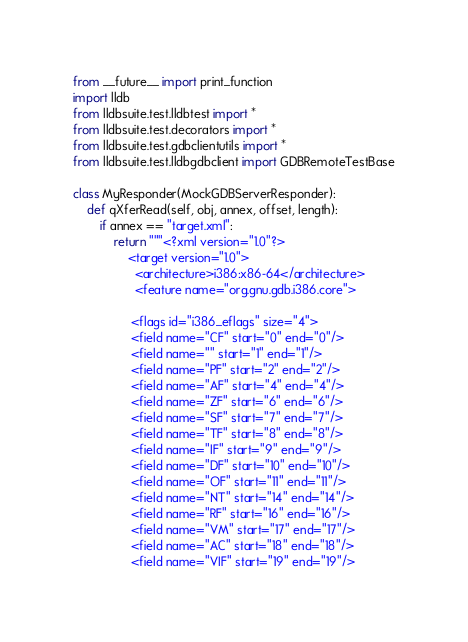Convert code to text. <code><loc_0><loc_0><loc_500><loc_500><_Python_>from __future__ import print_function
import lldb
from lldbsuite.test.lldbtest import *
from lldbsuite.test.decorators import *
from lldbsuite.test.gdbclientutils import *
from lldbsuite.test.lldbgdbclient import GDBRemoteTestBase

class MyResponder(MockGDBServerResponder):
    def qXferRead(self, obj, annex, offset, length):
        if annex == "target.xml":
            return """<?xml version="1.0"?>
                <target version="1.0">
                  <architecture>i386:x86-64</architecture>
                  <feature name="org.gnu.gdb.i386.core">

                 <flags id="i386_eflags" size="4">
                 <field name="CF" start="0" end="0"/>
                 <field name="" start="1" end="1"/>
                 <field name="PF" start="2" end="2"/>
                 <field name="AF" start="4" end="4"/>
                 <field name="ZF" start="6" end="6"/>
                 <field name="SF" start="7" end="7"/>
                 <field name="TF" start="8" end="8"/>
                 <field name="IF" start="9" end="9"/>
                 <field name="DF" start="10" end="10"/>
                 <field name="OF" start="11" end="11"/>
                 <field name="NT" start="14" end="14"/>
                 <field name="RF" start="16" end="16"/>
                 <field name="VM" start="17" end="17"/>
                 <field name="AC" start="18" end="18"/>
                 <field name="VIF" start="19" end="19"/></code> 